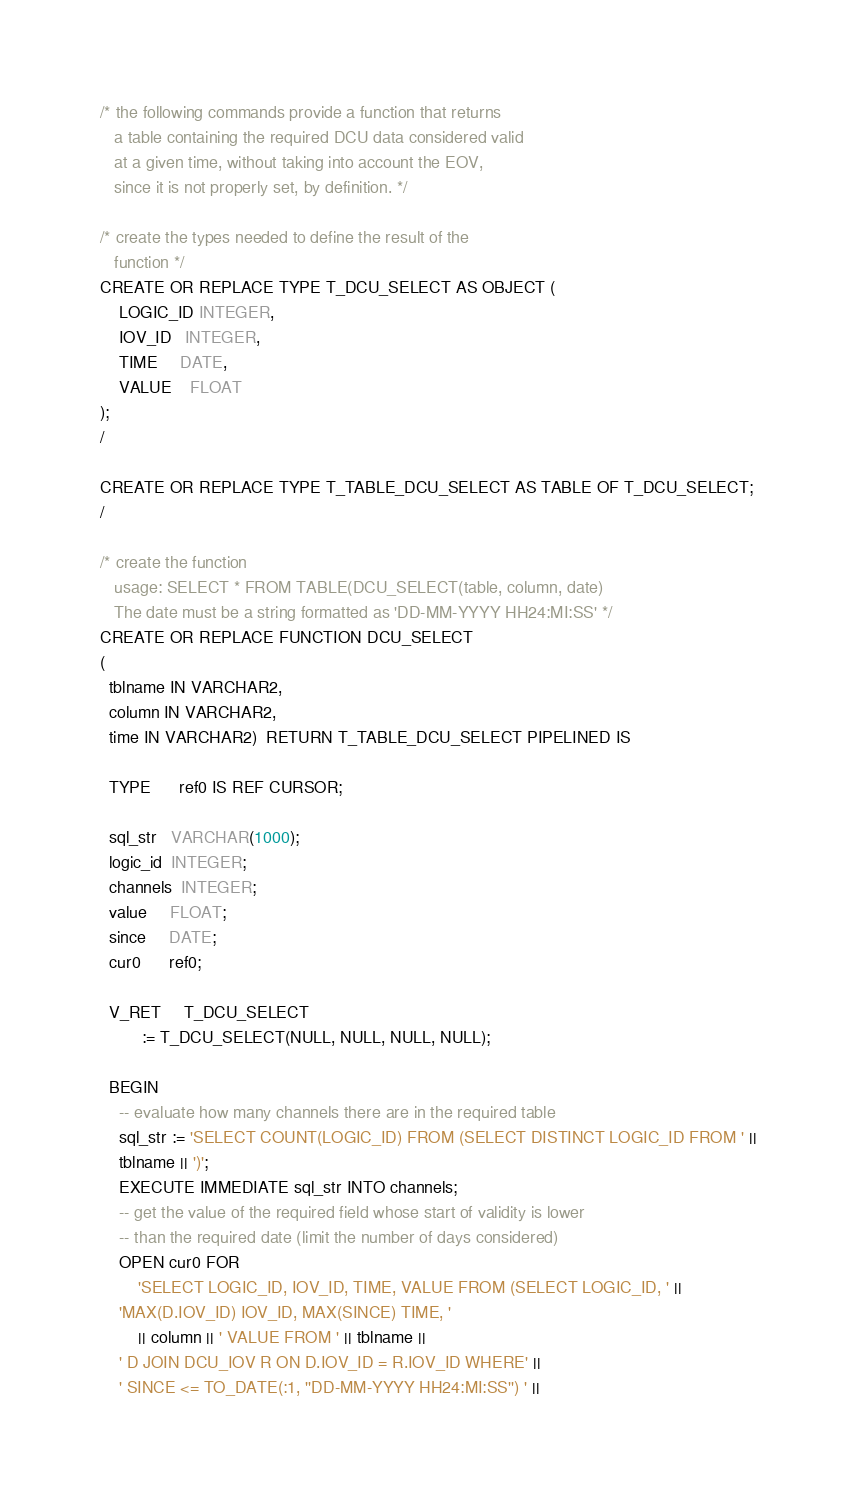<code> <loc_0><loc_0><loc_500><loc_500><_SQL_>/* the following commands provide a function that returns
   a table containing the required DCU data considered valid
   at a given time, without taking into account the EOV,
   since it is not properly set, by definition. */  

/* create the types needed to define the result of the
   function */
CREATE OR REPLACE TYPE T_DCU_SELECT AS OBJECT (
	LOGIC_ID INTEGER,
	IOV_ID   INTEGER,
	TIME     DATE,
	VALUE    FLOAT
);
/

CREATE OR REPLACE TYPE T_TABLE_DCU_SELECT AS TABLE OF T_DCU_SELECT;
/

/* create the function 
   usage: SELECT * FROM TABLE(DCU_SELECT(table, column, date)
   The date must be a string formatted as 'DD-MM-YYYY HH24:MI:SS' */
CREATE OR REPLACE FUNCTION DCU_SELECT
( 
  tblname IN VARCHAR2,
  column IN VARCHAR2,
  time IN VARCHAR2)  RETURN T_TABLE_DCU_SELECT PIPELINED IS

  TYPE      ref0 IS REF CURSOR;

  sql_str   VARCHAR(1000);
  logic_id  INTEGER;
  channels  INTEGER;
  value     FLOAT;
  since     DATE;
  cur0      ref0;	

  V_RET     T_DCU_SELECT
         := T_DCU_SELECT(NULL, NULL, NULL, NULL);

  BEGIN
    -- evaluate how many channels there are in the required table 
    sql_str := 'SELECT COUNT(LOGIC_ID) FROM (SELECT DISTINCT LOGIC_ID FROM ' ||
	tblname || ')';
    EXECUTE IMMEDIATE sql_str INTO channels;
    -- get the value of the required field whose start of validity is lower
    -- than the required date (limit the number of days considered)
    OPEN cur0 FOR 
        'SELECT LOGIC_ID, IOV_ID, TIME, VALUE FROM (SELECT LOGIC_ID, ' ||
	'MAX(D.IOV_ID) IOV_ID, MAX(SINCE) TIME, '
        || column || ' VALUE FROM ' || tblname || 
	' D JOIN DCU_IOV R ON D.IOV_ID = R.IOV_ID WHERE' ||
	' SINCE <= TO_DATE(:1, ''DD-MM-YYYY HH24:MI:SS'') ' ||</code> 